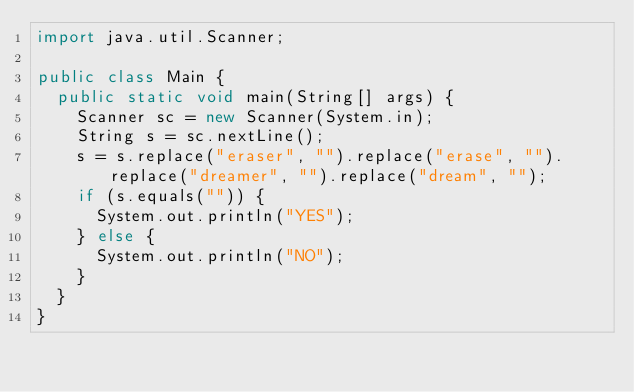<code> <loc_0><loc_0><loc_500><loc_500><_Java_>import java.util.Scanner;

public class Main {
  public static void main(String[] args) {
    Scanner sc = new Scanner(System.in);
    String s = sc.nextLine();
    s = s.replace("eraser", "").replace("erase", "").replace("dreamer", "").replace("dream", "");
    if (s.equals("")) {
      System.out.println("YES");
    } else {
      System.out.println("NO");
    }
  }
}
</code> 